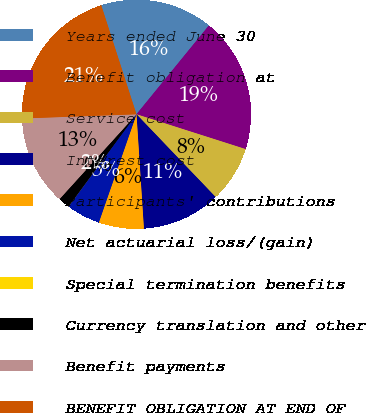Convert chart to OTSL. <chart><loc_0><loc_0><loc_500><loc_500><pie_chart><fcel>Years ended June 30<fcel>Benefit obligation at<fcel>Service cost<fcel>Interest cost<fcel>Participants' contributions<fcel>Net actuarial loss/(gain)<fcel>Special termination benefits<fcel>Currency translation and other<fcel>Benefit payments<fcel>BENEFIT OBLIGATION AT END OF<nl><fcel>15.86%<fcel>19.03%<fcel>7.94%<fcel>11.11%<fcel>6.36%<fcel>4.77%<fcel>0.02%<fcel>1.61%<fcel>12.69%<fcel>20.61%<nl></chart> 